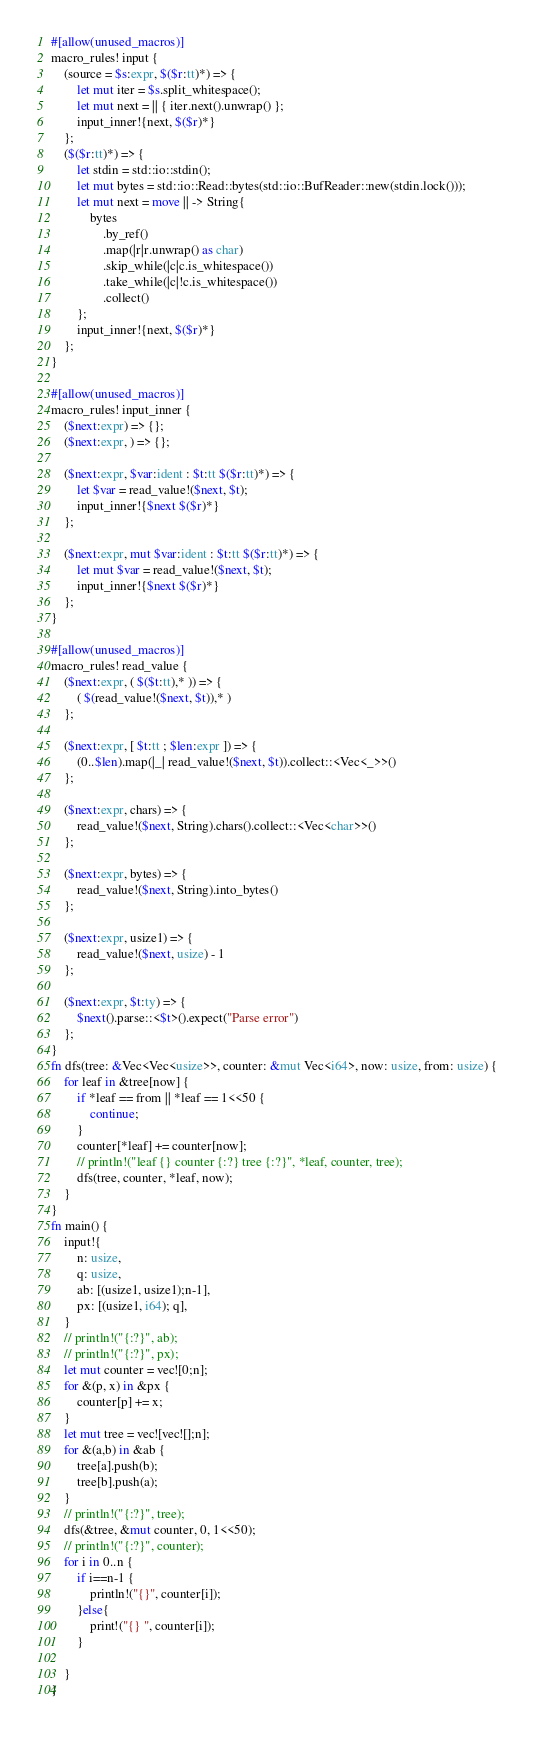Convert code to text. <code><loc_0><loc_0><loc_500><loc_500><_Rust_>#[allow(unused_macros)]
macro_rules! input {
    (source = $s:expr, $($r:tt)*) => {
        let mut iter = $s.split_whitespace();
        let mut next = || { iter.next().unwrap() };
        input_inner!{next, $($r)*}
    };
    ($($r:tt)*) => {
        let stdin = std::io::stdin();
        let mut bytes = std::io::Read::bytes(std::io::BufReader::new(stdin.lock()));
        let mut next = move || -> String{
            bytes
                .by_ref()
                .map(|r|r.unwrap() as char)
                .skip_while(|c|c.is_whitespace())
                .take_while(|c|!c.is_whitespace())
                .collect()
        };
        input_inner!{next, $($r)*}
    };
}

#[allow(unused_macros)]
macro_rules! input_inner {
    ($next:expr) => {};
    ($next:expr, ) => {};

    ($next:expr, $var:ident : $t:tt $($r:tt)*) => {
        let $var = read_value!($next, $t);
        input_inner!{$next $($r)*}
    };

    ($next:expr, mut $var:ident : $t:tt $($r:tt)*) => {
        let mut $var = read_value!($next, $t);
        input_inner!{$next $($r)*}
    };
}

#[allow(unused_macros)]
macro_rules! read_value {
    ($next:expr, ( $($t:tt),* )) => {
        ( $(read_value!($next, $t)),* )
    };

    ($next:expr, [ $t:tt ; $len:expr ]) => {
        (0..$len).map(|_| read_value!($next, $t)).collect::<Vec<_>>()
    };

    ($next:expr, chars) => {
        read_value!($next, String).chars().collect::<Vec<char>>()
    };

    ($next:expr, bytes) => {
        read_value!($next, String).into_bytes()
    };

    ($next:expr, usize1) => {
        read_value!($next, usize) - 1
    };

    ($next:expr, $t:ty) => {
        $next().parse::<$t>().expect("Parse error")
    };
}
fn dfs(tree: &Vec<Vec<usize>>, counter: &mut Vec<i64>, now: usize, from: usize) {
    for leaf in &tree[now] {
        if *leaf == from || *leaf == 1<<50 {
            continue;
        }
        counter[*leaf] += counter[now];
        // println!("leaf {} counter {:?} tree {:?}", *leaf, counter, tree);
        dfs(tree, counter, *leaf, now);
    }
}
fn main() {
    input!{
        n: usize,
        q: usize,
        ab: [(usize1, usize1);n-1],
        px: [(usize1, i64); q],
    }
    // println!("{:?}", ab);
    // println!("{:?}", px);
    let mut counter = vec![0;n];
    for &(p, x) in &px {
        counter[p] += x;
    }
    let mut tree = vec![vec![];n];
    for &(a,b) in &ab {
        tree[a].push(b);
        tree[b].push(a);
    }
    // println!("{:?}", tree);
    dfs(&tree, &mut counter, 0, 1<<50);
    // println!("{:?}", counter);
    for i in 0..n {
        if i==n-1 {
            println!("{}", counter[i]);
        }else{
            print!("{} ", counter[i]);
        }

    }
}</code> 